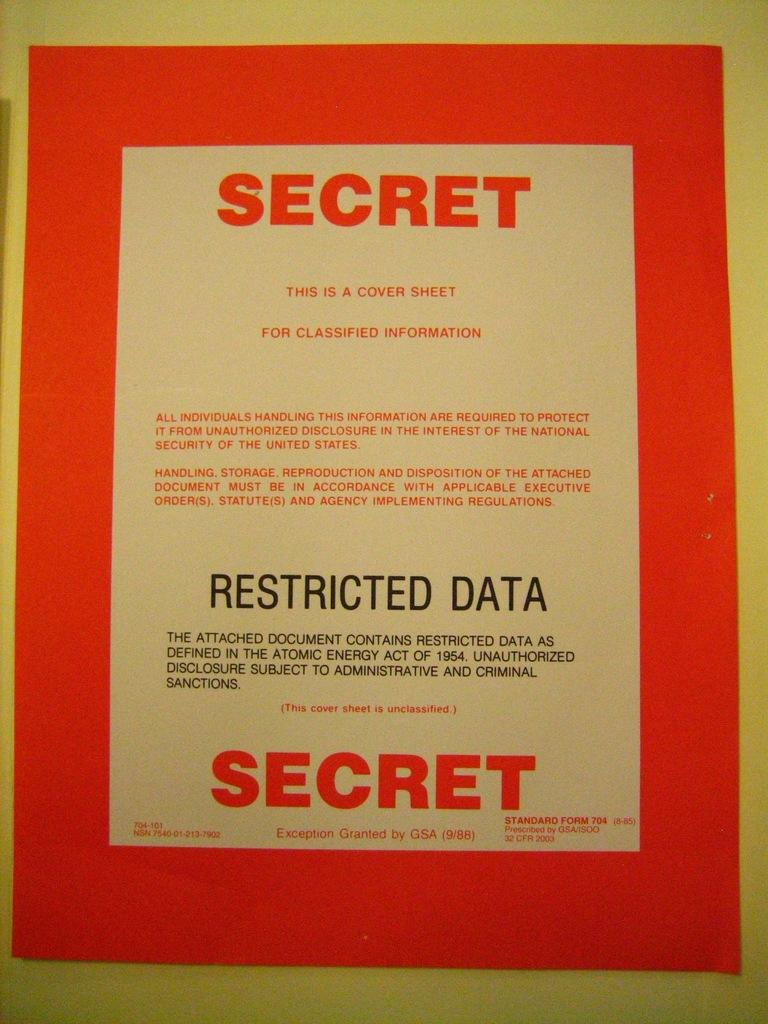<image>
Describe the image concisely. a red and white sign with secret printed in red at the top and bottom 